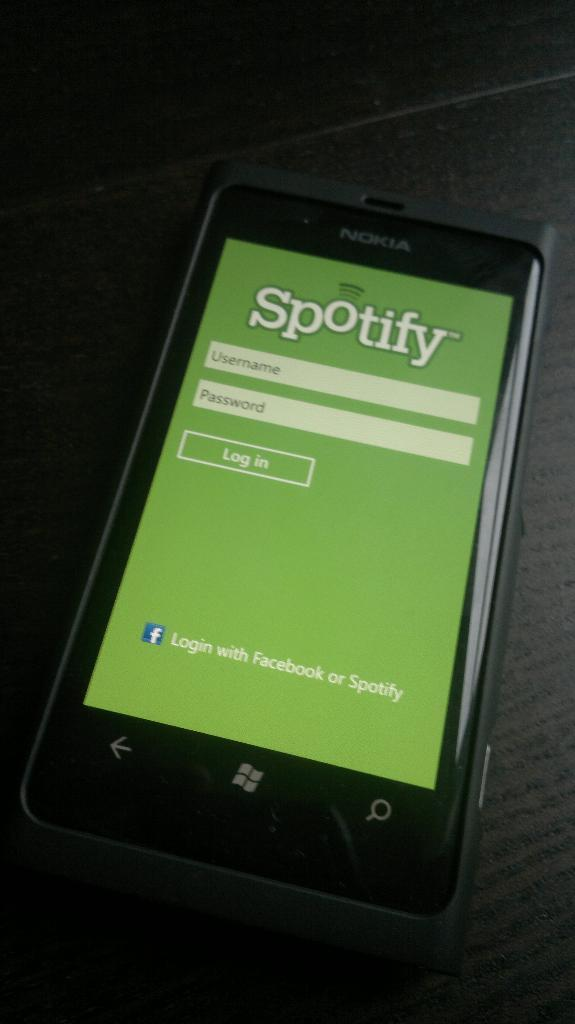<image>
Offer a succinct explanation of the picture presented. A phone with the app Spotify pulled up on it. 